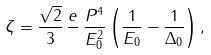Convert formula to latex. <formula><loc_0><loc_0><loc_500><loc_500>\zeta = \frac { \sqrt { 2 } } { 3 } \, \frac { e } { } \, \frac { P ^ { 4 } } { E _ { 0 } ^ { 2 } } \left ( \frac { 1 } { E _ { 0 } } - \frac { 1 } { \Delta _ { 0 } } \right ) ,</formula> 